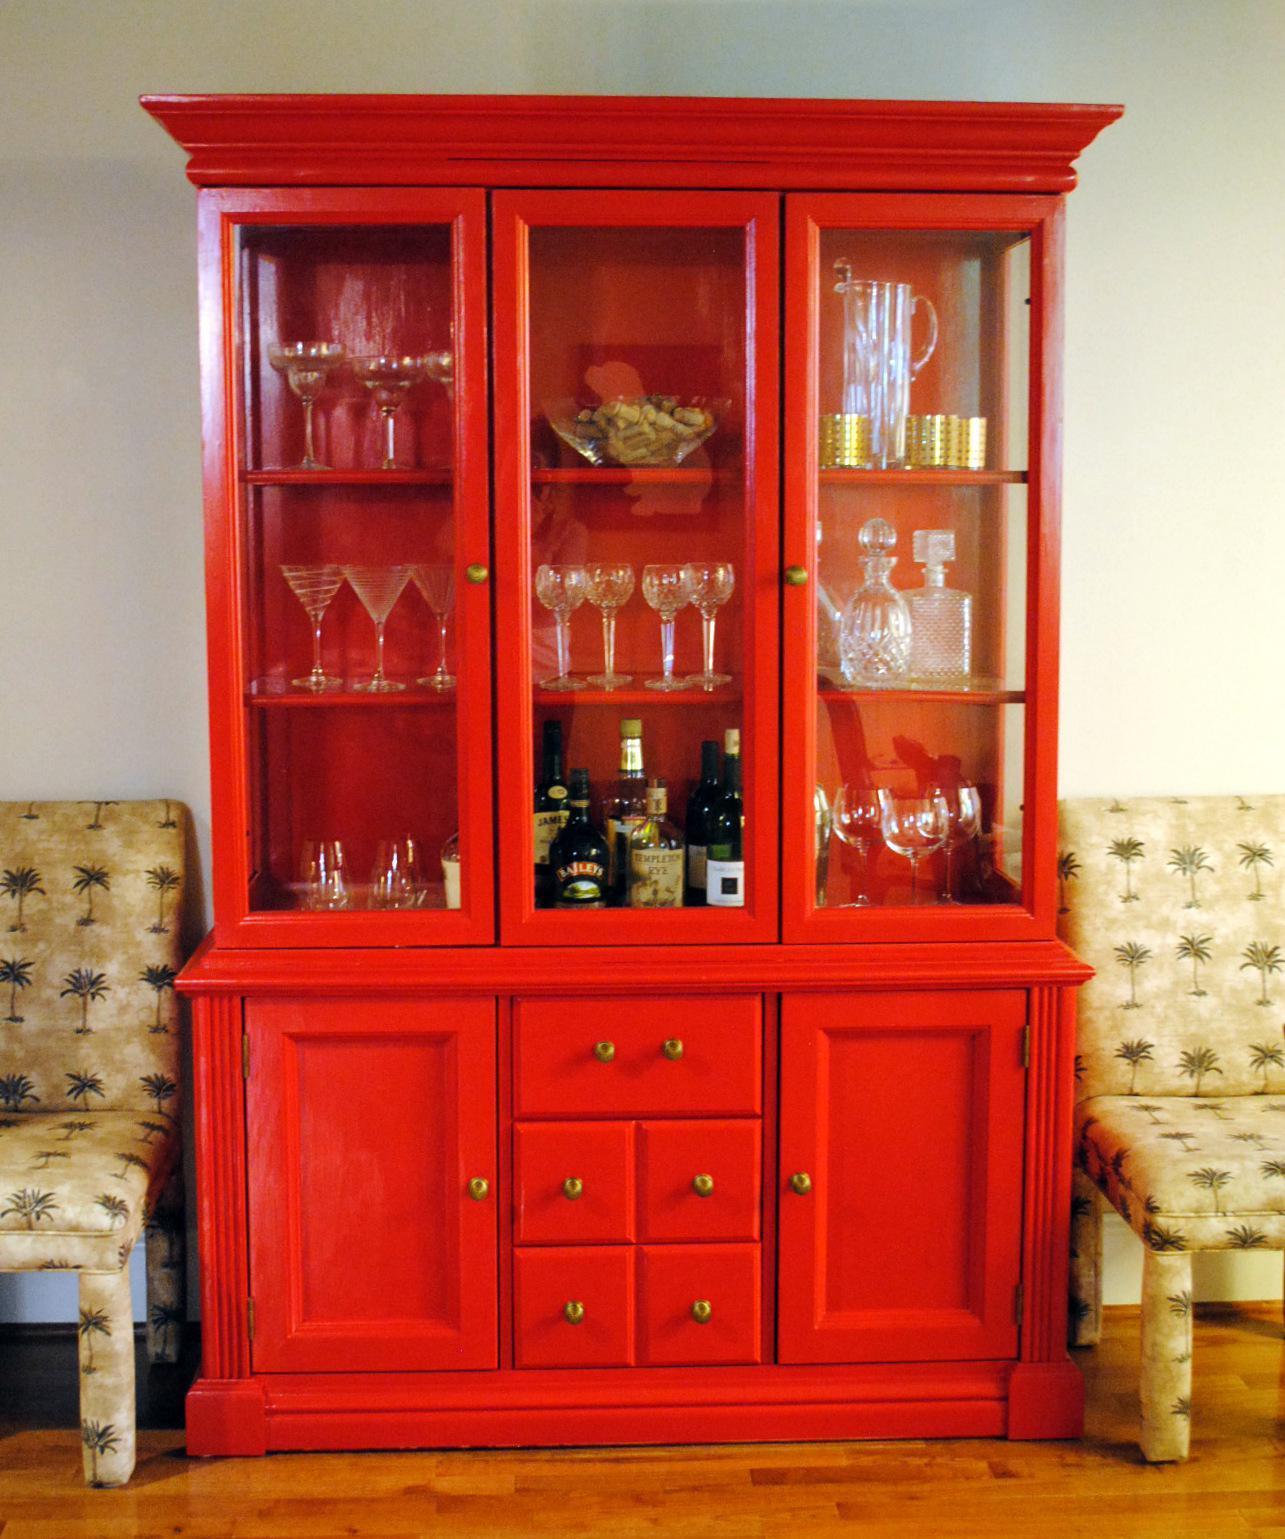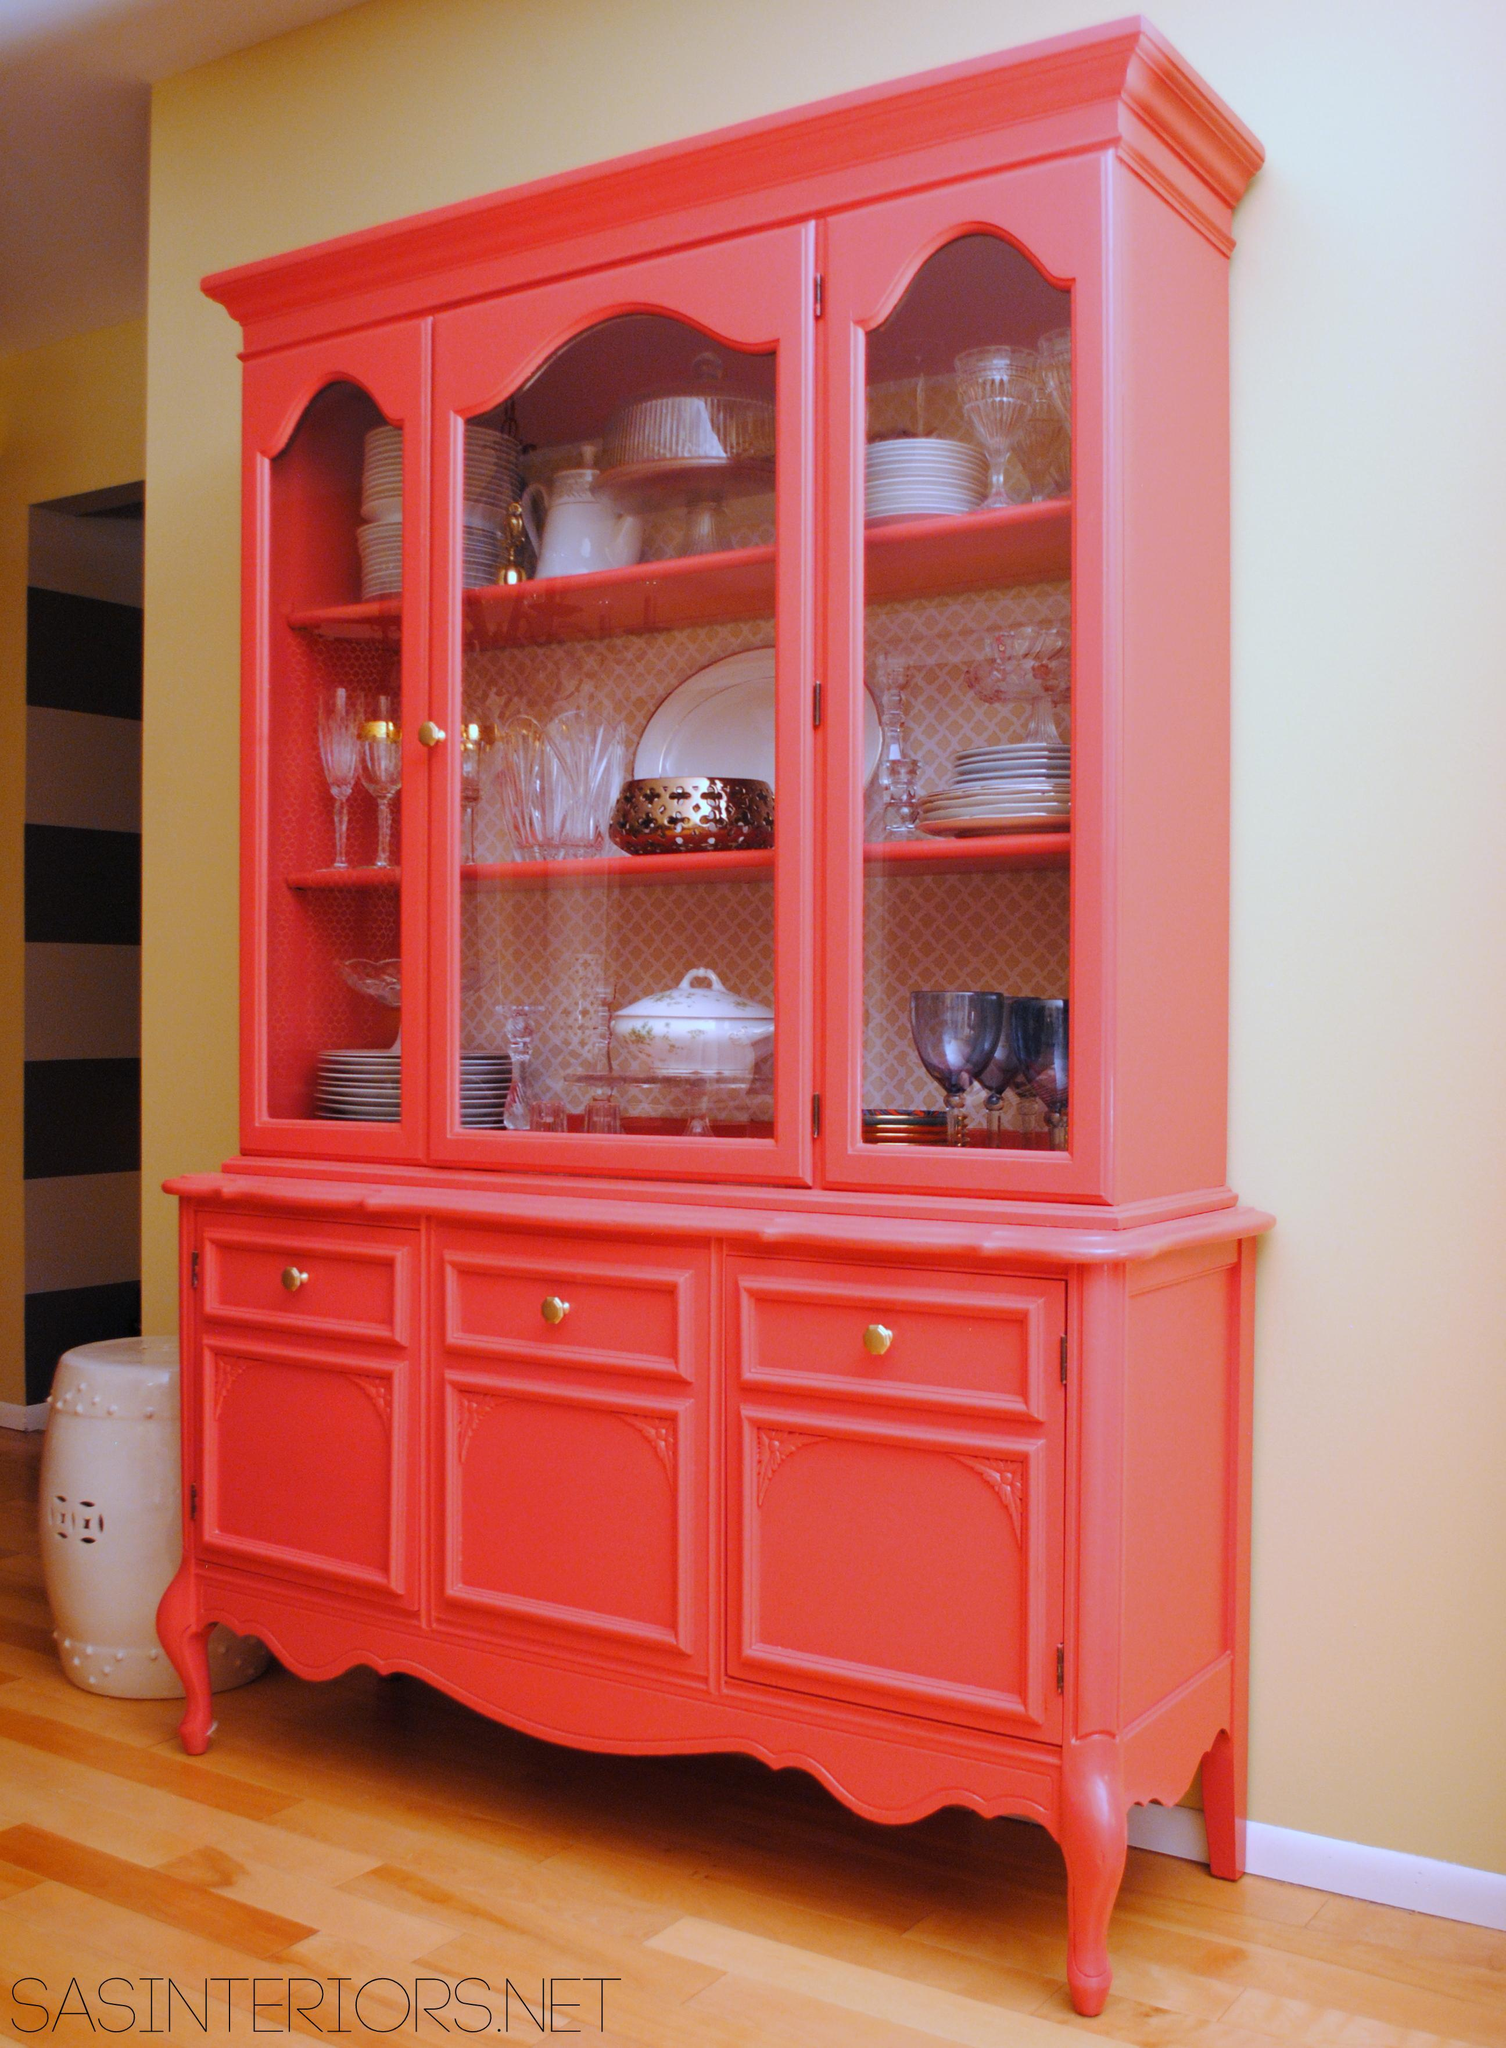The first image is the image on the left, the second image is the image on the right. Examine the images to the left and right. Is the description "There are exactly three drawers on the cabinet in the image on the right." accurate? Answer yes or no. Yes. 